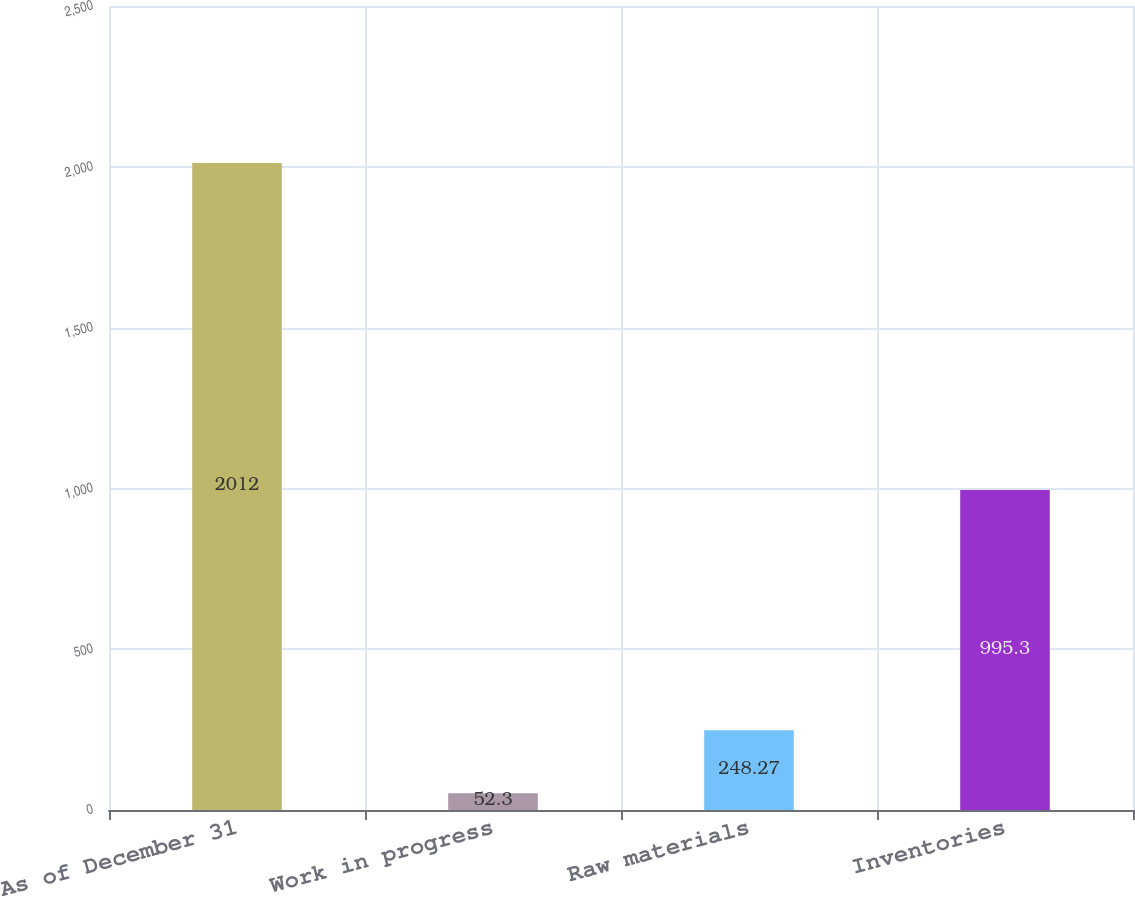Convert chart. <chart><loc_0><loc_0><loc_500><loc_500><bar_chart><fcel>As of December 31<fcel>Work in progress<fcel>Raw materials<fcel>Inventories<nl><fcel>2012<fcel>52.3<fcel>248.27<fcel>995.3<nl></chart> 